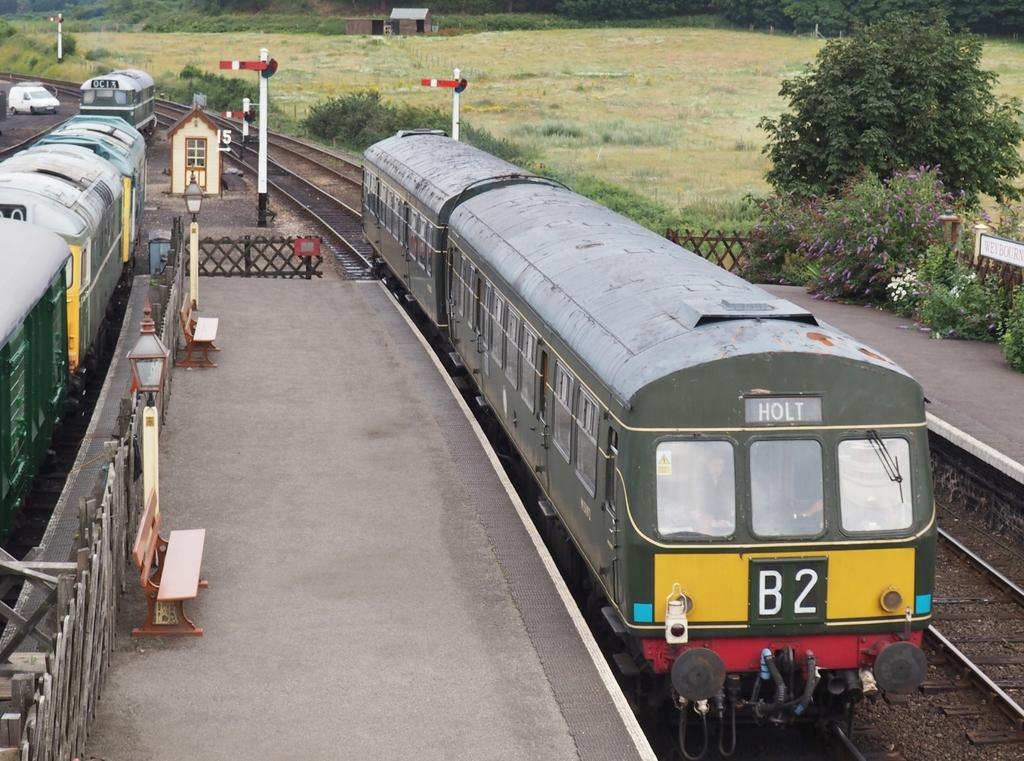<image>
Write a terse but informative summary of the picture. A train marked B2 on the front is headed for Holt. 